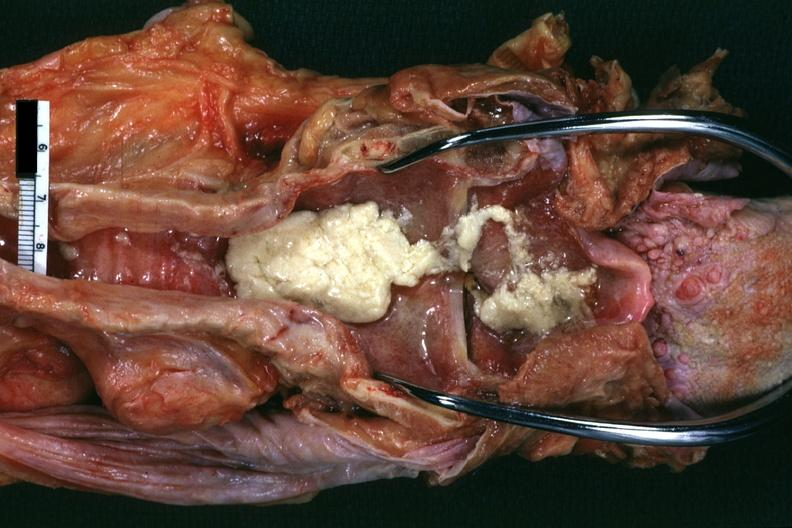what is present?
Answer the question using a single word or phrase. Larynx 